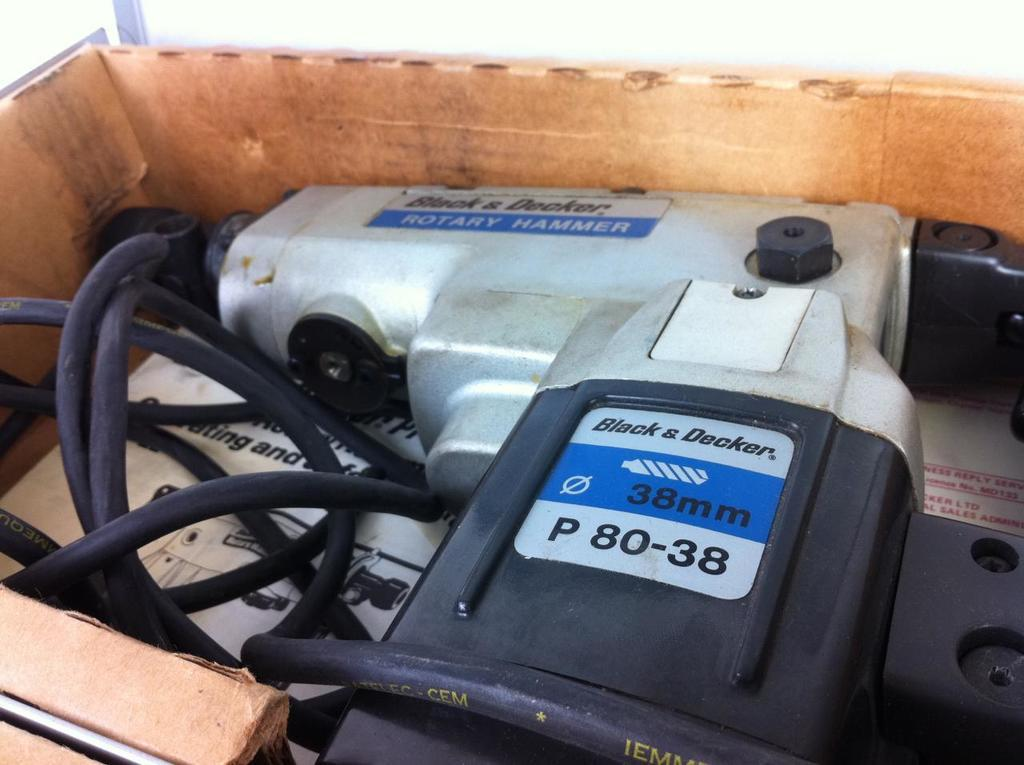What is the main object in the image? There is an object that looks like a drill machine in the image. What else can be seen in the image besides the drill machine? There are wires in the image. Is there any paper present in the image? Yes, there is a paper in a box in the image. What type of nut is being used to hold the committee together in the image? There is no committee or nut present in the image. 